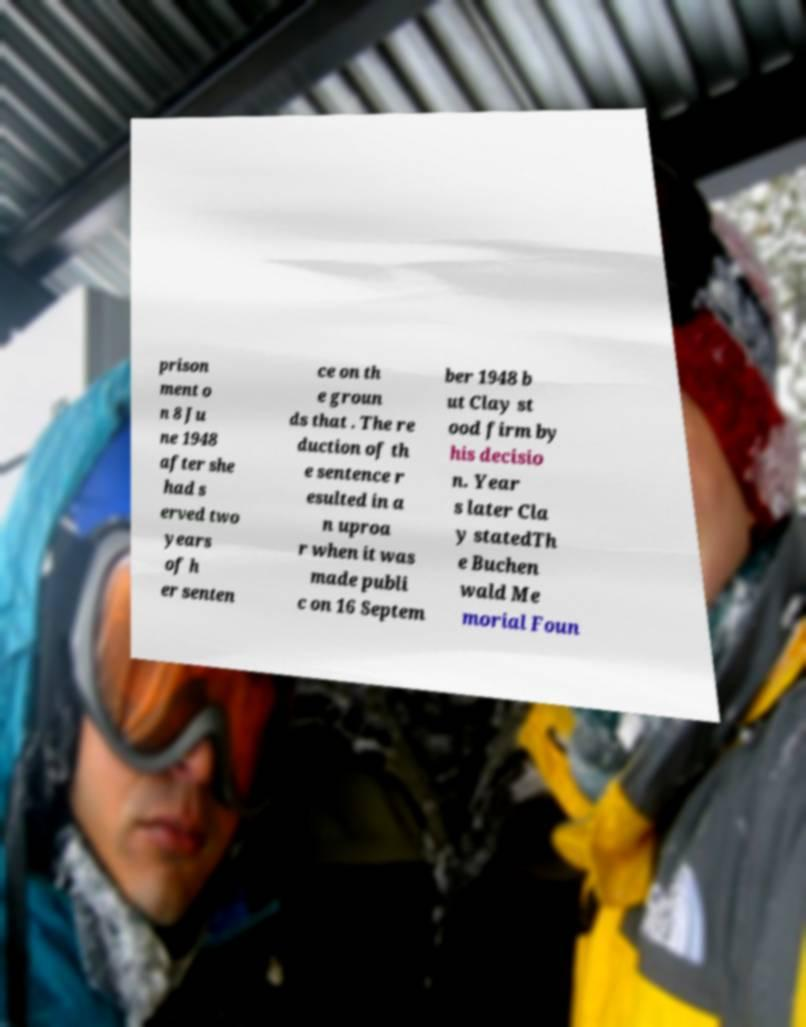There's text embedded in this image that I need extracted. Can you transcribe it verbatim? prison ment o n 8 Ju ne 1948 after she had s erved two years of h er senten ce on th e groun ds that . The re duction of th e sentence r esulted in a n uproa r when it was made publi c on 16 Septem ber 1948 b ut Clay st ood firm by his decisio n. Year s later Cla y statedTh e Buchen wald Me morial Foun 